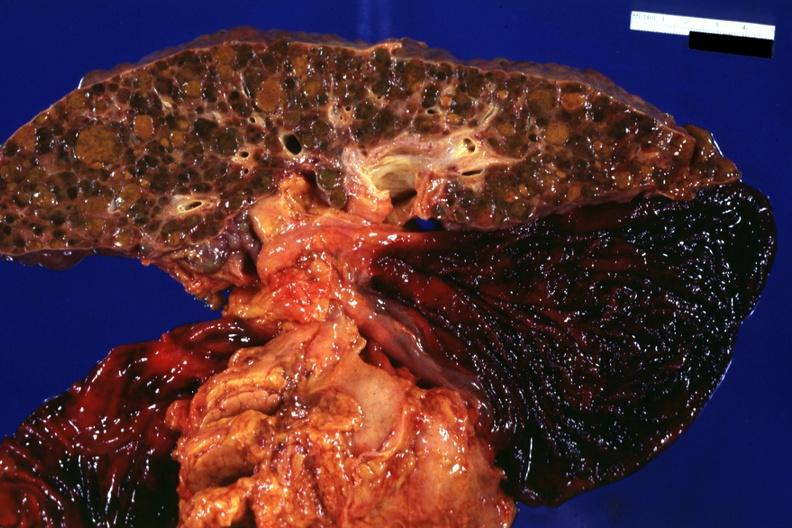s liver present?
Answer the question using a single word or phrase. Yes 